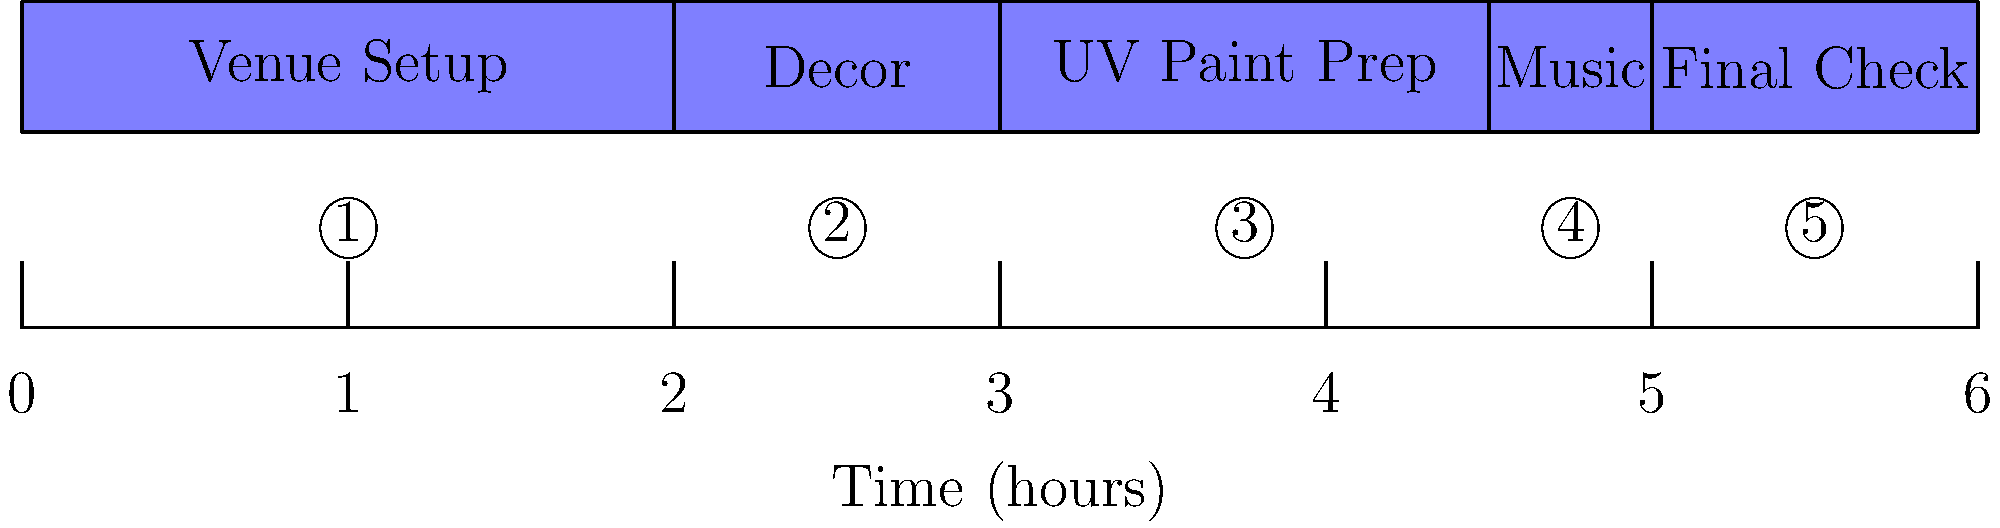Based on the timeline of party preparation tasks for a neon body painting event, how long does the entire preparation process take? To determine the total preparation time, we need to add up the durations of all tasks:

1. Venue Setup: 2 hours
2. Decor: 1 hour
3. UV Paint Prep: 1.5 hours
4. Music: 0.5 hours
5. Final Check: 1 hour

Adding these durations:
$2 + 1 + 1.5 + 0.5 + 1 = 6$ hours

The timeline also shows that the entire process spans from 0 to 6 on the time axis, confirming our calculation.
Answer: 6 hours 